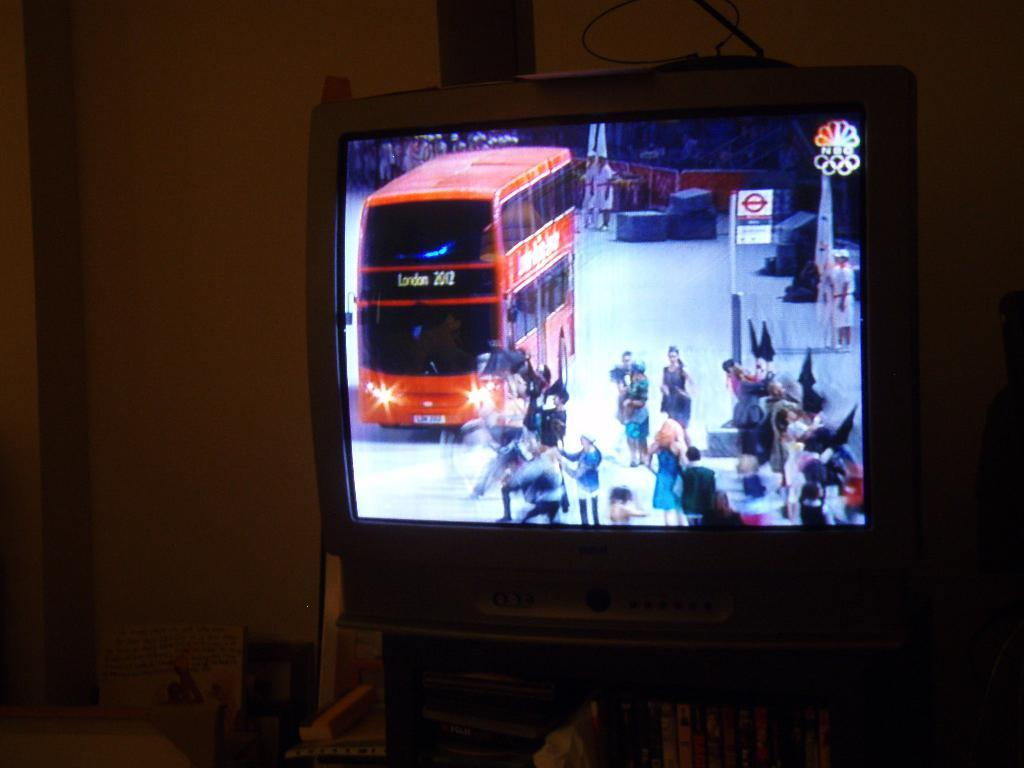<image>
Present a compact description of the photo's key features. A bus on the television is heading towards London 2012. 